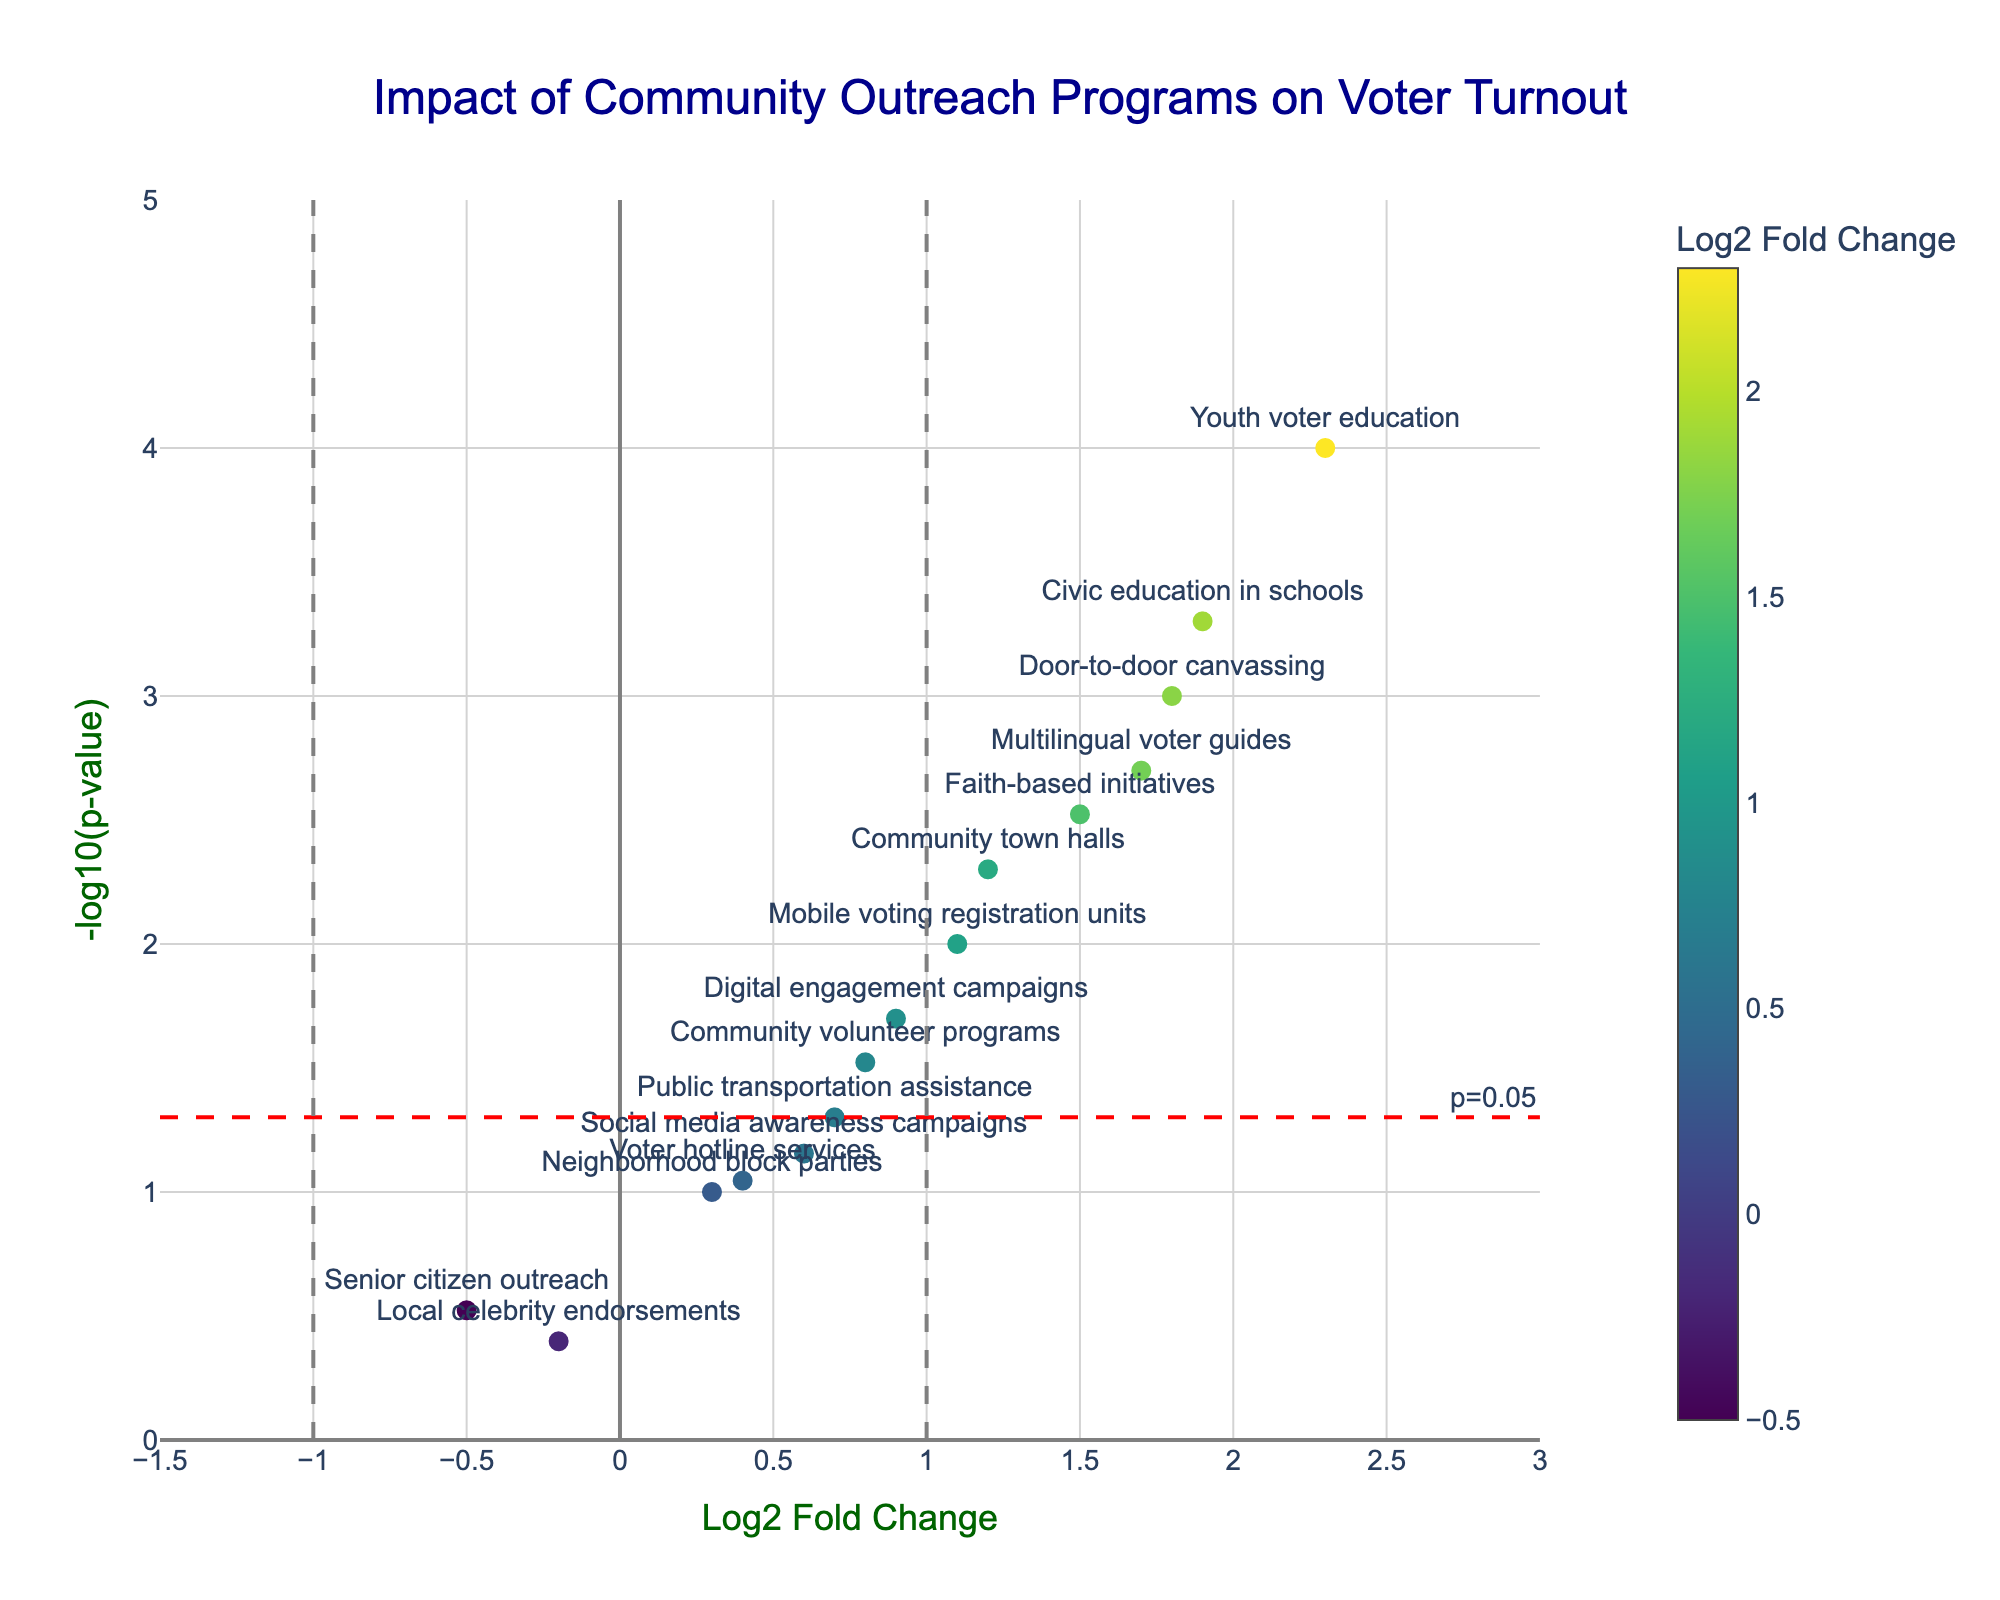what's the title of the figure? The title of the figure is located at the top center and it reads "Impact of Community Outreach Programs on Voter Turnout"
Answer: Impact of Community Outreach Programs on Voter Turnout what's the vertical axis representing? The label on the vertical axis is "-log10(p-value)", which indicates it represents the negative logarithm of the p-value of the community outreach programs.
Answer: -log10(p-value) how many data points are there in the plot? Each marker in the plot represents a community outreach program, which can be counted from the data. By counting the programs listed, we find there are 15 data points.
Answer: 15 which program has the highest impact on voter turnout? To determine the highest impact, we look for the data point with the highest Log2 Fold Change value. "Youth voter education" has the highest Log2 Fold Change value of 2.3.
Answer: Youth voter education which programs have a statistically significant impact on voter turnout? Programs are considered statistically significant if their p-value is below 0.05, which corresponds to a -log10(p-value) above -log10(0.05) ≈ 1.3. The plot indicates these programs: "Door-to-door canvassing", "Community town halls", "Youth voter education", "Faith-based initiatives", "Multilingual voter guides", "Mobile voting registration units", and "Civic education in schools".
Answer: Door-to-door canvassing, Community town halls, Youth voter education, Faith-based initiatives, Multilingual voter guides, Mobile voting registration units, Civic education in schools which program shows a negative impact that is not statistically significant? We look for data points with a negative Log2 Fold Change and a -log10(p-value) below approximately 1.3. "Senior citizen outreach" and "Local celebrity endorsements" meet both criteria, but only one shows negative impact which is "Senior citizen outreach".
Answer: Senior citizen outreach how many programs fall within the range of -1.5 to 3 on the Log2 Fold Change axis? Observing the x-axis, we see that all data points fall within this range. Therefore, all 15 programs fall within this range.
Answer: 15 what's the fold change threshold indicated by the vertical lines? The plot shows vertical lines at Log2 Fold Change values of -1 and 1, suggesting these values act as the thresholds.
Answer: -1 and 1 which program has the second highest statistical significance? Statistical significance is indicated by the highest -log10(p-value) values. The program "Civic education in schools" has the second highest -log10(p-value) of approximately 3.3.
Answer: Civic education in schools what's the p-value threshold indicated by the horizontal line? The horizontal line corresponds to a p-value threshold of 0.05, resulting in -log10(0.05) which is approximately 1.3.
Answer: 0.05 